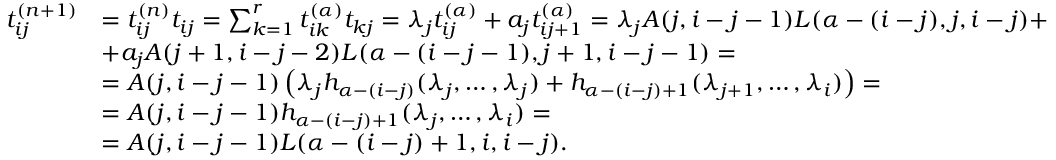Convert formula to latex. <formula><loc_0><loc_0><loc_500><loc_500>\begin{array} { r l } { t _ { i j } ^ { ( n + 1 ) } } & { = t _ { i j } ^ { ( n ) } t _ { i j } = \sum _ { k = 1 } ^ { r } t _ { i k } ^ { ( \alpha ) } t _ { k j } = \lambda _ { j } t _ { i j } ^ { ( \alpha ) } + a _ { j } t _ { i j + 1 } ^ { ( \alpha ) } = \lambda _ { j } A ( j , i - j - 1 ) L ( \alpha - ( i - j ) , j , i - j ) + } \\ & { + a _ { j } A ( j + 1 , i - j - 2 ) L ( \alpha - ( i - j - 1 ) , j + 1 , i - j - 1 ) = } \\ & { = A ( j , i - j - 1 ) \left ( \lambda _ { j } h _ { \alpha - ( i - j ) } ( \lambda _ { j } , \dots , \lambda _ { j } ) + h _ { \alpha - ( i - j ) + 1 } ( \lambda _ { j + 1 } , \dots , \lambda _ { i } ) \right ) = } \\ & { = A ( j , i - j - 1 ) h _ { \alpha - ( i - j ) + 1 } ( \lambda _ { j } , \dots , \lambda _ { i } ) = } \\ & { = A ( j , i - j - 1 ) L ( \alpha - ( i - j ) + 1 , i , i - j ) . } \end{array}</formula> 